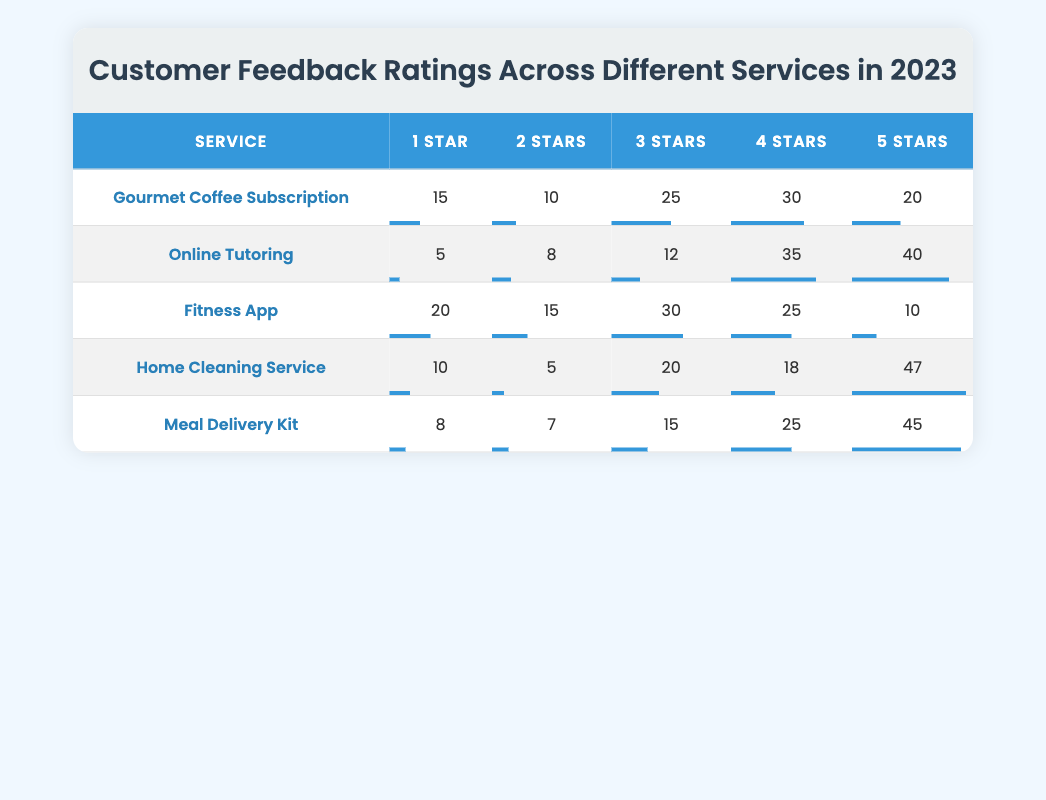What service received the highest number of 5-star ratings? By reviewing the 5-star ratings column, the Home Cleaning Service has 47 ratings, which is higher than the other services: Gourmet Coffee Subscription (20), Online Tutoring (40), Fitness App (10), and Meal Delivery Kit (45). Thus, Home Cleaning Service has the highest 5-star ratings.
Answer: Home Cleaning Service What is the total number of 1-star ratings across all services? To find the total 1-star ratings, we add the values from the 1-star column: 15 (Gourmet Coffee) + 5 (Online Tutoring) + 20 (Fitness App) + 10 (Home Cleaning) + 8 (Meal Delivery Kit) = 58.
Answer: 58 Which service has the fewest total ratings? Total ratings for each service are computed by adding all the ratings together. Gourmet Coffee: 15 + 10 + 25 + 30 + 20 = 110, Online Tutoring: 5 + 8 + 12 + 35 + 40 = 100, Fitness App: 20 + 15 + 30 + 25 + 10 = 100, Home Cleaning: 10 + 5 + 20 + 18 + 47 = 100, Meal Delivery Kit: 8 + 7 + 15 + 25 + 45 = 100. All services except Gourmet Coffee have a total of 100 ratings, so the fewest total ratings are tied among Online Tutoring, Fitness App, Home Cleaning Service, and Meal Delivery Kit.
Answer: Online Tutoring, Fitness App, Home Cleaning Service, Meal Delivery Kit Is the average rating for the Fitness App higher than that of the Gourmet Coffee Subscription? To compute the average, we find the total ratings and divide by the number of different ratings (5). For Fitness App: (20*1 + 15*2 + 30*3 + 25*4 + 10*5) / 100 = 2.5. For Gourmet Coffee Subscription: (15*1 + 10*2 + 25*3 + 30*4 + 20*5) / 110 = 3.2. Therefore, 2.5 < 3.2, indicating that the average rating for the Fitness App is not higher than that for Gourmet Coffee Subscription.
Answer: No What is the difference between the number of 4-star and 1-star ratings for the Meal Delivery Kit? For Meal Delivery Kit, the number of 4-star ratings is 25, and the number of 1-star ratings is 8. The difference is calculated as 25 - 8 = 17.
Answer: 17 Which rating has the highest count across all services? By comparing the counts for each star rating across all services: 1 Star: 58, 2 Stars: 45, 3 Stars: 112, 4 Stars: 148, and 5 Stars: 162. The highest count is in the 5-Star ratings with a total of 162.
Answer: 5 Stars What percentage of ratings were 5 stars for Online Tutoring? The total ratings for Online Tutoring is 100 (sum of all ratings), with 40 being 5 stars. The percentage is (40/100) * 100 = 40%.
Answer: 40% What is the average number of 3-star ratings across all services? We sum the 3-star ratings: 25 (Gourmet Coffee) + 12 (Online Tutoring) + 30 (Fitness App) + 20 (Home Cleaning) + 15 (Meal Delivery Kit) = 112. The average across the 5 services is 112/5 = 22.4.
Answer: 22.4 